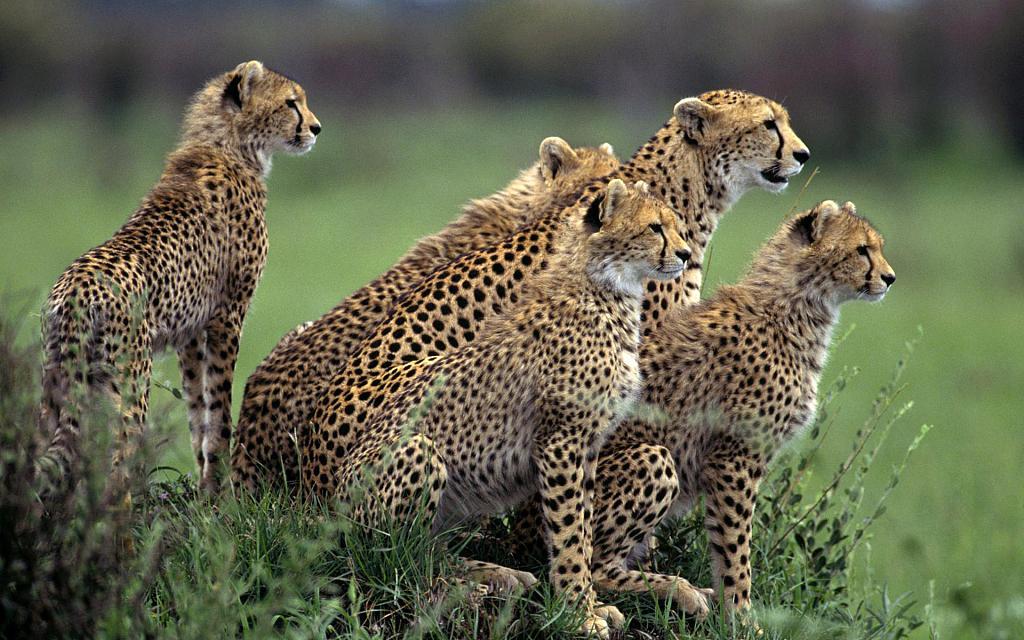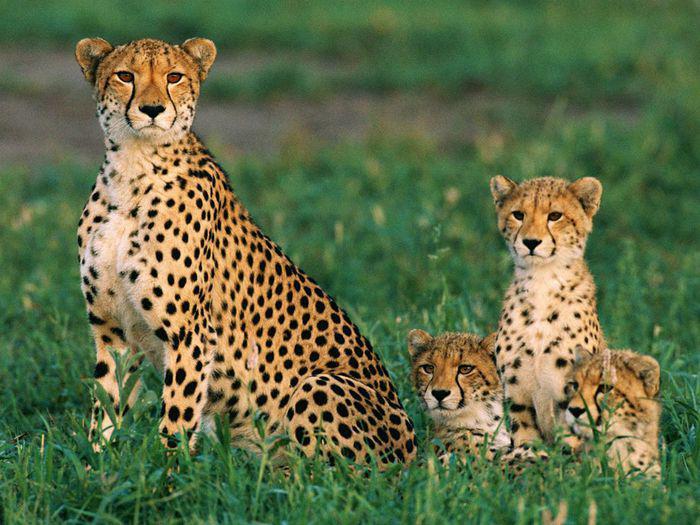The first image is the image on the left, the second image is the image on the right. Examine the images to the left and right. Is the description "An image shows one spotted wild cat pursuing its prey." accurate? Answer yes or no. No. The first image is the image on the left, the second image is the image on the right. For the images shown, is this caption "The leopard on the left is running after its prey." true? Answer yes or no. No. 